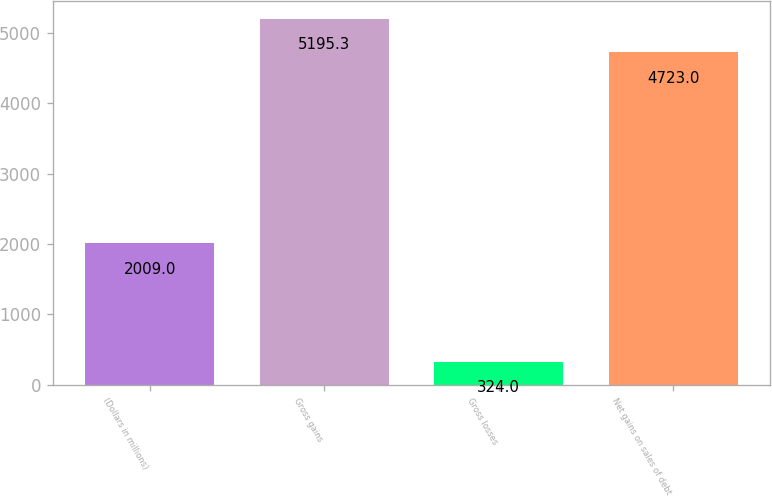<chart> <loc_0><loc_0><loc_500><loc_500><bar_chart><fcel>(Dollars in millions)<fcel>Gross gains<fcel>Gross losses<fcel>Net gains on sales of debt<nl><fcel>2009<fcel>5195.3<fcel>324<fcel>4723<nl></chart> 